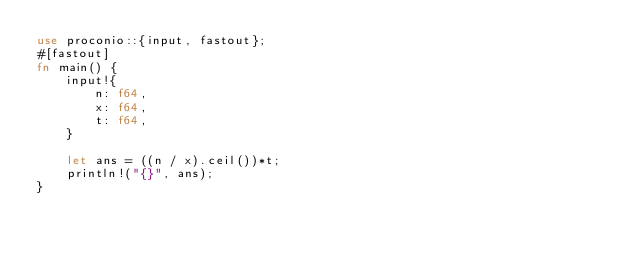<code> <loc_0><loc_0><loc_500><loc_500><_Rust_>use proconio::{input, fastout};
#[fastout]
fn main() {
    input!{
        n: f64,
        x: f64, 
        t: f64,
    }

    let ans = ((n / x).ceil())*t;
    println!("{}", ans);
}
</code> 